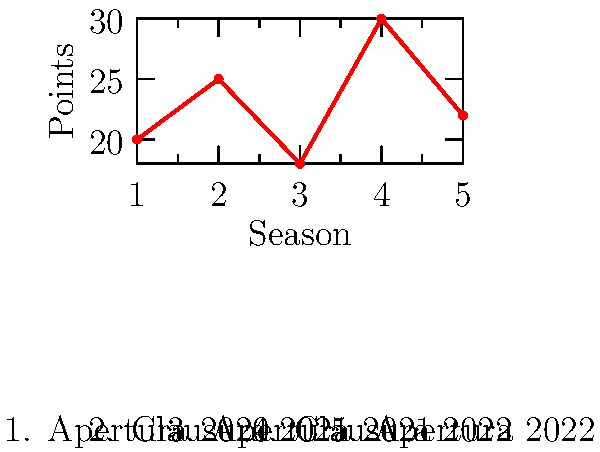Based on the line graph showing Mazatlán F.C.'s performance in Liga MX over five seasons, in which season did the team achieve their highest points total? To determine the season with the highest points total for Mazatlán F.C., we need to analyze the graph step-by-step:

1. The x-axis represents the seasons, numbered from 1 to 5.
2. The y-axis represents the points earned in each season.
3. We can see five data points on the graph, each corresponding to a season:
   - Season 1 (Apertura 2020): 20 points
   - Season 2 (Clausura 2021): 25 points
   - Season 3 (Apertura 2021): 18 points
   - Season 4 (Clausura 2022): 30 points
   - Season 5 (Apertura 2022): 22 points
4. Comparing these point totals, we can see that the highest peak on the graph corresponds to Season 4 (Clausura 2022).
5. The point total for Season 4 is 30, which is the highest among all seasons shown.

Therefore, Mazatlán F.C. achieved their highest points total in Season 4, which corresponds to the Clausura 2022 tournament.
Answer: Clausura 2022 